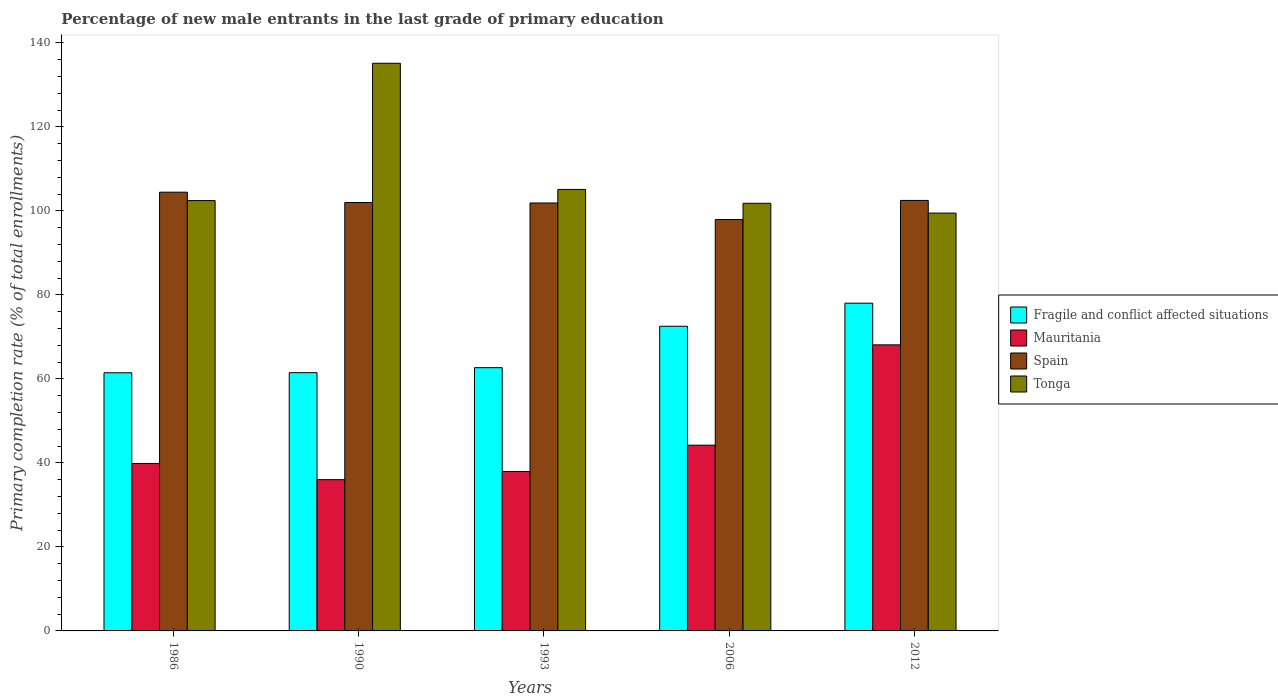How many groups of bars are there?
Offer a very short reply. 5. Are the number of bars per tick equal to the number of legend labels?
Ensure brevity in your answer.  Yes. Are the number of bars on each tick of the X-axis equal?
Provide a short and direct response. Yes. How many bars are there on the 2nd tick from the left?
Keep it short and to the point. 4. What is the percentage of new male entrants in Tonga in 2012?
Provide a succinct answer. 99.47. Across all years, what is the maximum percentage of new male entrants in Fragile and conflict affected situations?
Offer a very short reply. 78.02. Across all years, what is the minimum percentage of new male entrants in Mauritania?
Offer a terse response. 36.01. In which year was the percentage of new male entrants in Fragile and conflict affected situations minimum?
Make the answer very short. 1986. What is the total percentage of new male entrants in Mauritania in the graph?
Your answer should be very brief. 226.16. What is the difference between the percentage of new male entrants in Fragile and conflict affected situations in 1990 and that in 2006?
Offer a very short reply. -11.04. What is the difference between the percentage of new male entrants in Fragile and conflict affected situations in 1993 and the percentage of new male entrants in Spain in 1990?
Your answer should be very brief. -39.32. What is the average percentage of new male entrants in Fragile and conflict affected situations per year?
Your answer should be very brief. 67.23. In the year 1993, what is the difference between the percentage of new male entrants in Fragile and conflict affected situations and percentage of new male entrants in Mauritania?
Make the answer very short. 24.71. What is the ratio of the percentage of new male entrants in Spain in 1993 to that in 2006?
Offer a very short reply. 1.04. What is the difference between the highest and the second highest percentage of new male entrants in Spain?
Give a very brief answer. 1.96. What is the difference between the highest and the lowest percentage of new male entrants in Fragile and conflict affected situations?
Offer a very short reply. 16.56. In how many years, is the percentage of new male entrants in Spain greater than the average percentage of new male entrants in Spain taken over all years?
Keep it short and to the point. 4. Is it the case that in every year, the sum of the percentage of new male entrants in Tonga and percentage of new male entrants in Mauritania is greater than the sum of percentage of new male entrants in Fragile and conflict affected situations and percentage of new male entrants in Spain?
Keep it short and to the point. Yes. What does the 3rd bar from the left in 1990 represents?
Your answer should be very brief. Spain. What does the 1st bar from the right in 2012 represents?
Ensure brevity in your answer.  Tonga. Is it the case that in every year, the sum of the percentage of new male entrants in Tonga and percentage of new male entrants in Fragile and conflict affected situations is greater than the percentage of new male entrants in Spain?
Your answer should be very brief. Yes. Are all the bars in the graph horizontal?
Offer a terse response. No. How many years are there in the graph?
Offer a very short reply. 5. What is the difference between two consecutive major ticks on the Y-axis?
Offer a terse response. 20. Are the values on the major ticks of Y-axis written in scientific E-notation?
Provide a succinct answer. No. Does the graph contain grids?
Provide a succinct answer. No. How many legend labels are there?
Offer a terse response. 4. How are the legend labels stacked?
Your answer should be very brief. Vertical. What is the title of the graph?
Your answer should be very brief. Percentage of new male entrants in the last grade of primary education. Does "Syrian Arab Republic" appear as one of the legend labels in the graph?
Provide a succinct answer. No. What is the label or title of the X-axis?
Provide a succinct answer. Years. What is the label or title of the Y-axis?
Your response must be concise. Primary completion rate (% of total enrollments). What is the Primary completion rate (% of total enrollments) of Fragile and conflict affected situations in 1986?
Your response must be concise. 61.46. What is the Primary completion rate (% of total enrollments) in Mauritania in 1986?
Provide a short and direct response. 39.87. What is the Primary completion rate (% of total enrollments) of Spain in 1986?
Give a very brief answer. 104.44. What is the Primary completion rate (% of total enrollments) in Tonga in 1986?
Keep it short and to the point. 102.45. What is the Primary completion rate (% of total enrollments) in Fragile and conflict affected situations in 1990?
Your response must be concise. 61.48. What is the Primary completion rate (% of total enrollments) in Mauritania in 1990?
Ensure brevity in your answer.  36.01. What is the Primary completion rate (% of total enrollments) in Spain in 1990?
Ensure brevity in your answer.  101.98. What is the Primary completion rate (% of total enrollments) of Tonga in 1990?
Offer a very short reply. 135.14. What is the Primary completion rate (% of total enrollments) of Fragile and conflict affected situations in 1993?
Provide a short and direct response. 62.67. What is the Primary completion rate (% of total enrollments) of Mauritania in 1993?
Offer a terse response. 37.96. What is the Primary completion rate (% of total enrollments) in Spain in 1993?
Provide a succinct answer. 101.87. What is the Primary completion rate (% of total enrollments) of Tonga in 1993?
Provide a succinct answer. 105.1. What is the Primary completion rate (% of total enrollments) of Fragile and conflict affected situations in 2006?
Keep it short and to the point. 72.52. What is the Primary completion rate (% of total enrollments) in Mauritania in 2006?
Provide a short and direct response. 44.22. What is the Primary completion rate (% of total enrollments) in Spain in 2006?
Keep it short and to the point. 97.93. What is the Primary completion rate (% of total enrollments) in Tonga in 2006?
Your response must be concise. 101.8. What is the Primary completion rate (% of total enrollments) in Fragile and conflict affected situations in 2012?
Provide a succinct answer. 78.02. What is the Primary completion rate (% of total enrollments) in Mauritania in 2012?
Provide a short and direct response. 68.1. What is the Primary completion rate (% of total enrollments) of Spain in 2012?
Your answer should be compact. 102.48. What is the Primary completion rate (% of total enrollments) in Tonga in 2012?
Your answer should be very brief. 99.47. Across all years, what is the maximum Primary completion rate (% of total enrollments) in Fragile and conflict affected situations?
Make the answer very short. 78.02. Across all years, what is the maximum Primary completion rate (% of total enrollments) of Mauritania?
Offer a very short reply. 68.1. Across all years, what is the maximum Primary completion rate (% of total enrollments) of Spain?
Offer a terse response. 104.44. Across all years, what is the maximum Primary completion rate (% of total enrollments) of Tonga?
Keep it short and to the point. 135.14. Across all years, what is the minimum Primary completion rate (% of total enrollments) of Fragile and conflict affected situations?
Your answer should be compact. 61.46. Across all years, what is the minimum Primary completion rate (% of total enrollments) in Mauritania?
Offer a terse response. 36.01. Across all years, what is the minimum Primary completion rate (% of total enrollments) of Spain?
Offer a terse response. 97.93. Across all years, what is the minimum Primary completion rate (% of total enrollments) of Tonga?
Keep it short and to the point. 99.47. What is the total Primary completion rate (% of total enrollments) of Fragile and conflict affected situations in the graph?
Provide a short and direct response. 336.15. What is the total Primary completion rate (% of total enrollments) in Mauritania in the graph?
Your answer should be compact. 226.16. What is the total Primary completion rate (% of total enrollments) in Spain in the graph?
Your answer should be very brief. 508.71. What is the total Primary completion rate (% of total enrollments) in Tonga in the graph?
Keep it short and to the point. 543.95. What is the difference between the Primary completion rate (% of total enrollments) of Fragile and conflict affected situations in 1986 and that in 1990?
Provide a short and direct response. -0.02. What is the difference between the Primary completion rate (% of total enrollments) in Mauritania in 1986 and that in 1990?
Keep it short and to the point. 3.85. What is the difference between the Primary completion rate (% of total enrollments) of Spain in 1986 and that in 1990?
Make the answer very short. 2.46. What is the difference between the Primary completion rate (% of total enrollments) of Tonga in 1986 and that in 1990?
Provide a short and direct response. -32.69. What is the difference between the Primary completion rate (% of total enrollments) in Fragile and conflict affected situations in 1986 and that in 1993?
Offer a terse response. -1.21. What is the difference between the Primary completion rate (% of total enrollments) in Mauritania in 1986 and that in 1993?
Your answer should be very brief. 1.91. What is the difference between the Primary completion rate (% of total enrollments) of Spain in 1986 and that in 1993?
Your answer should be compact. 2.57. What is the difference between the Primary completion rate (% of total enrollments) in Tonga in 1986 and that in 1993?
Make the answer very short. -2.65. What is the difference between the Primary completion rate (% of total enrollments) in Fragile and conflict affected situations in 1986 and that in 2006?
Provide a succinct answer. -11.07. What is the difference between the Primary completion rate (% of total enrollments) of Mauritania in 1986 and that in 2006?
Your response must be concise. -4.36. What is the difference between the Primary completion rate (% of total enrollments) in Spain in 1986 and that in 2006?
Give a very brief answer. 6.51. What is the difference between the Primary completion rate (% of total enrollments) of Tonga in 1986 and that in 2006?
Your answer should be very brief. 0.65. What is the difference between the Primary completion rate (% of total enrollments) of Fragile and conflict affected situations in 1986 and that in 2012?
Your answer should be compact. -16.56. What is the difference between the Primary completion rate (% of total enrollments) of Mauritania in 1986 and that in 2012?
Your response must be concise. -28.24. What is the difference between the Primary completion rate (% of total enrollments) of Spain in 1986 and that in 2012?
Offer a terse response. 1.96. What is the difference between the Primary completion rate (% of total enrollments) in Tonga in 1986 and that in 2012?
Your answer should be very brief. 2.98. What is the difference between the Primary completion rate (% of total enrollments) in Fragile and conflict affected situations in 1990 and that in 1993?
Your response must be concise. -1.19. What is the difference between the Primary completion rate (% of total enrollments) in Mauritania in 1990 and that in 1993?
Ensure brevity in your answer.  -1.94. What is the difference between the Primary completion rate (% of total enrollments) in Spain in 1990 and that in 1993?
Your answer should be compact. 0.11. What is the difference between the Primary completion rate (% of total enrollments) of Tonga in 1990 and that in 1993?
Your answer should be compact. 30.04. What is the difference between the Primary completion rate (% of total enrollments) in Fragile and conflict affected situations in 1990 and that in 2006?
Provide a succinct answer. -11.04. What is the difference between the Primary completion rate (% of total enrollments) in Mauritania in 1990 and that in 2006?
Your answer should be very brief. -8.21. What is the difference between the Primary completion rate (% of total enrollments) in Spain in 1990 and that in 2006?
Your answer should be compact. 4.05. What is the difference between the Primary completion rate (% of total enrollments) in Tonga in 1990 and that in 2006?
Keep it short and to the point. 33.34. What is the difference between the Primary completion rate (% of total enrollments) in Fragile and conflict affected situations in 1990 and that in 2012?
Provide a succinct answer. -16.54. What is the difference between the Primary completion rate (% of total enrollments) in Mauritania in 1990 and that in 2012?
Make the answer very short. -32.09. What is the difference between the Primary completion rate (% of total enrollments) of Spain in 1990 and that in 2012?
Offer a terse response. -0.5. What is the difference between the Primary completion rate (% of total enrollments) in Tonga in 1990 and that in 2012?
Provide a short and direct response. 35.67. What is the difference between the Primary completion rate (% of total enrollments) of Fragile and conflict affected situations in 1993 and that in 2006?
Ensure brevity in your answer.  -9.86. What is the difference between the Primary completion rate (% of total enrollments) in Mauritania in 1993 and that in 2006?
Offer a terse response. -6.27. What is the difference between the Primary completion rate (% of total enrollments) of Spain in 1993 and that in 2006?
Make the answer very short. 3.94. What is the difference between the Primary completion rate (% of total enrollments) in Tonga in 1993 and that in 2006?
Offer a very short reply. 3.3. What is the difference between the Primary completion rate (% of total enrollments) of Fragile and conflict affected situations in 1993 and that in 2012?
Your answer should be very brief. -15.35. What is the difference between the Primary completion rate (% of total enrollments) in Mauritania in 1993 and that in 2012?
Offer a terse response. -30.15. What is the difference between the Primary completion rate (% of total enrollments) of Spain in 1993 and that in 2012?
Keep it short and to the point. -0.61. What is the difference between the Primary completion rate (% of total enrollments) in Tonga in 1993 and that in 2012?
Your response must be concise. 5.63. What is the difference between the Primary completion rate (% of total enrollments) of Fragile and conflict affected situations in 2006 and that in 2012?
Provide a short and direct response. -5.49. What is the difference between the Primary completion rate (% of total enrollments) in Mauritania in 2006 and that in 2012?
Your answer should be very brief. -23.88. What is the difference between the Primary completion rate (% of total enrollments) of Spain in 2006 and that in 2012?
Give a very brief answer. -4.55. What is the difference between the Primary completion rate (% of total enrollments) in Tonga in 2006 and that in 2012?
Your response must be concise. 2.33. What is the difference between the Primary completion rate (% of total enrollments) of Fragile and conflict affected situations in 1986 and the Primary completion rate (% of total enrollments) of Mauritania in 1990?
Ensure brevity in your answer.  25.44. What is the difference between the Primary completion rate (% of total enrollments) in Fragile and conflict affected situations in 1986 and the Primary completion rate (% of total enrollments) in Spain in 1990?
Your answer should be very brief. -40.53. What is the difference between the Primary completion rate (% of total enrollments) of Fragile and conflict affected situations in 1986 and the Primary completion rate (% of total enrollments) of Tonga in 1990?
Your response must be concise. -73.68. What is the difference between the Primary completion rate (% of total enrollments) of Mauritania in 1986 and the Primary completion rate (% of total enrollments) of Spain in 1990?
Your answer should be very brief. -62.12. What is the difference between the Primary completion rate (% of total enrollments) of Mauritania in 1986 and the Primary completion rate (% of total enrollments) of Tonga in 1990?
Your answer should be very brief. -95.27. What is the difference between the Primary completion rate (% of total enrollments) of Spain in 1986 and the Primary completion rate (% of total enrollments) of Tonga in 1990?
Your answer should be very brief. -30.69. What is the difference between the Primary completion rate (% of total enrollments) of Fragile and conflict affected situations in 1986 and the Primary completion rate (% of total enrollments) of Mauritania in 1993?
Provide a short and direct response. 23.5. What is the difference between the Primary completion rate (% of total enrollments) in Fragile and conflict affected situations in 1986 and the Primary completion rate (% of total enrollments) in Spain in 1993?
Your answer should be very brief. -40.41. What is the difference between the Primary completion rate (% of total enrollments) in Fragile and conflict affected situations in 1986 and the Primary completion rate (% of total enrollments) in Tonga in 1993?
Offer a very short reply. -43.64. What is the difference between the Primary completion rate (% of total enrollments) in Mauritania in 1986 and the Primary completion rate (% of total enrollments) in Spain in 1993?
Offer a terse response. -62. What is the difference between the Primary completion rate (% of total enrollments) in Mauritania in 1986 and the Primary completion rate (% of total enrollments) in Tonga in 1993?
Make the answer very short. -65.23. What is the difference between the Primary completion rate (% of total enrollments) of Spain in 1986 and the Primary completion rate (% of total enrollments) of Tonga in 1993?
Your response must be concise. -0.65. What is the difference between the Primary completion rate (% of total enrollments) of Fragile and conflict affected situations in 1986 and the Primary completion rate (% of total enrollments) of Mauritania in 2006?
Provide a succinct answer. 17.23. What is the difference between the Primary completion rate (% of total enrollments) in Fragile and conflict affected situations in 1986 and the Primary completion rate (% of total enrollments) in Spain in 2006?
Your response must be concise. -36.48. What is the difference between the Primary completion rate (% of total enrollments) of Fragile and conflict affected situations in 1986 and the Primary completion rate (% of total enrollments) of Tonga in 2006?
Your response must be concise. -40.34. What is the difference between the Primary completion rate (% of total enrollments) in Mauritania in 1986 and the Primary completion rate (% of total enrollments) in Spain in 2006?
Your answer should be compact. -58.07. What is the difference between the Primary completion rate (% of total enrollments) in Mauritania in 1986 and the Primary completion rate (% of total enrollments) in Tonga in 2006?
Your response must be concise. -61.93. What is the difference between the Primary completion rate (% of total enrollments) in Spain in 1986 and the Primary completion rate (% of total enrollments) in Tonga in 2006?
Ensure brevity in your answer.  2.65. What is the difference between the Primary completion rate (% of total enrollments) of Fragile and conflict affected situations in 1986 and the Primary completion rate (% of total enrollments) of Mauritania in 2012?
Your response must be concise. -6.65. What is the difference between the Primary completion rate (% of total enrollments) in Fragile and conflict affected situations in 1986 and the Primary completion rate (% of total enrollments) in Spain in 2012?
Keep it short and to the point. -41.02. What is the difference between the Primary completion rate (% of total enrollments) in Fragile and conflict affected situations in 1986 and the Primary completion rate (% of total enrollments) in Tonga in 2012?
Your answer should be compact. -38.01. What is the difference between the Primary completion rate (% of total enrollments) in Mauritania in 1986 and the Primary completion rate (% of total enrollments) in Spain in 2012?
Ensure brevity in your answer.  -62.62. What is the difference between the Primary completion rate (% of total enrollments) in Mauritania in 1986 and the Primary completion rate (% of total enrollments) in Tonga in 2012?
Make the answer very short. -59.6. What is the difference between the Primary completion rate (% of total enrollments) in Spain in 1986 and the Primary completion rate (% of total enrollments) in Tonga in 2012?
Make the answer very short. 4.98. What is the difference between the Primary completion rate (% of total enrollments) of Fragile and conflict affected situations in 1990 and the Primary completion rate (% of total enrollments) of Mauritania in 1993?
Provide a short and direct response. 23.52. What is the difference between the Primary completion rate (% of total enrollments) in Fragile and conflict affected situations in 1990 and the Primary completion rate (% of total enrollments) in Spain in 1993?
Keep it short and to the point. -40.39. What is the difference between the Primary completion rate (% of total enrollments) in Fragile and conflict affected situations in 1990 and the Primary completion rate (% of total enrollments) in Tonga in 1993?
Give a very brief answer. -43.62. What is the difference between the Primary completion rate (% of total enrollments) in Mauritania in 1990 and the Primary completion rate (% of total enrollments) in Spain in 1993?
Your answer should be compact. -65.86. What is the difference between the Primary completion rate (% of total enrollments) in Mauritania in 1990 and the Primary completion rate (% of total enrollments) in Tonga in 1993?
Provide a short and direct response. -69.09. What is the difference between the Primary completion rate (% of total enrollments) of Spain in 1990 and the Primary completion rate (% of total enrollments) of Tonga in 1993?
Offer a very short reply. -3.11. What is the difference between the Primary completion rate (% of total enrollments) in Fragile and conflict affected situations in 1990 and the Primary completion rate (% of total enrollments) in Mauritania in 2006?
Provide a succinct answer. 17.26. What is the difference between the Primary completion rate (% of total enrollments) in Fragile and conflict affected situations in 1990 and the Primary completion rate (% of total enrollments) in Spain in 2006?
Your answer should be compact. -36.45. What is the difference between the Primary completion rate (% of total enrollments) of Fragile and conflict affected situations in 1990 and the Primary completion rate (% of total enrollments) of Tonga in 2006?
Offer a very short reply. -40.32. What is the difference between the Primary completion rate (% of total enrollments) in Mauritania in 1990 and the Primary completion rate (% of total enrollments) in Spain in 2006?
Provide a succinct answer. -61.92. What is the difference between the Primary completion rate (% of total enrollments) in Mauritania in 1990 and the Primary completion rate (% of total enrollments) in Tonga in 2006?
Your response must be concise. -65.79. What is the difference between the Primary completion rate (% of total enrollments) in Spain in 1990 and the Primary completion rate (% of total enrollments) in Tonga in 2006?
Your answer should be very brief. 0.19. What is the difference between the Primary completion rate (% of total enrollments) of Fragile and conflict affected situations in 1990 and the Primary completion rate (% of total enrollments) of Mauritania in 2012?
Provide a short and direct response. -6.62. What is the difference between the Primary completion rate (% of total enrollments) of Fragile and conflict affected situations in 1990 and the Primary completion rate (% of total enrollments) of Spain in 2012?
Your answer should be very brief. -41. What is the difference between the Primary completion rate (% of total enrollments) of Fragile and conflict affected situations in 1990 and the Primary completion rate (% of total enrollments) of Tonga in 2012?
Provide a succinct answer. -37.99. What is the difference between the Primary completion rate (% of total enrollments) in Mauritania in 1990 and the Primary completion rate (% of total enrollments) in Spain in 2012?
Keep it short and to the point. -66.47. What is the difference between the Primary completion rate (% of total enrollments) of Mauritania in 1990 and the Primary completion rate (% of total enrollments) of Tonga in 2012?
Make the answer very short. -63.46. What is the difference between the Primary completion rate (% of total enrollments) of Spain in 1990 and the Primary completion rate (% of total enrollments) of Tonga in 2012?
Keep it short and to the point. 2.52. What is the difference between the Primary completion rate (% of total enrollments) in Fragile and conflict affected situations in 1993 and the Primary completion rate (% of total enrollments) in Mauritania in 2006?
Give a very brief answer. 18.45. What is the difference between the Primary completion rate (% of total enrollments) of Fragile and conflict affected situations in 1993 and the Primary completion rate (% of total enrollments) of Spain in 2006?
Ensure brevity in your answer.  -35.26. What is the difference between the Primary completion rate (% of total enrollments) in Fragile and conflict affected situations in 1993 and the Primary completion rate (% of total enrollments) in Tonga in 2006?
Make the answer very short. -39.13. What is the difference between the Primary completion rate (% of total enrollments) in Mauritania in 1993 and the Primary completion rate (% of total enrollments) in Spain in 2006?
Ensure brevity in your answer.  -59.98. What is the difference between the Primary completion rate (% of total enrollments) of Mauritania in 1993 and the Primary completion rate (% of total enrollments) of Tonga in 2006?
Give a very brief answer. -63.84. What is the difference between the Primary completion rate (% of total enrollments) of Spain in 1993 and the Primary completion rate (% of total enrollments) of Tonga in 2006?
Your response must be concise. 0.07. What is the difference between the Primary completion rate (% of total enrollments) in Fragile and conflict affected situations in 1993 and the Primary completion rate (% of total enrollments) in Mauritania in 2012?
Offer a very short reply. -5.43. What is the difference between the Primary completion rate (% of total enrollments) in Fragile and conflict affected situations in 1993 and the Primary completion rate (% of total enrollments) in Spain in 2012?
Your answer should be very brief. -39.81. What is the difference between the Primary completion rate (% of total enrollments) in Fragile and conflict affected situations in 1993 and the Primary completion rate (% of total enrollments) in Tonga in 2012?
Your answer should be very brief. -36.8. What is the difference between the Primary completion rate (% of total enrollments) in Mauritania in 1993 and the Primary completion rate (% of total enrollments) in Spain in 2012?
Your answer should be very brief. -64.52. What is the difference between the Primary completion rate (% of total enrollments) in Mauritania in 1993 and the Primary completion rate (% of total enrollments) in Tonga in 2012?
Ensure brevity in your answer.  -61.51. What is the difference between the Primary completion rate (% of total enrollments) of Spain in 1993 and the Primary completion rate (% of total enrollments) of Tonga in 2012?
Keep it short and to the point. 2.4. What is the difference between the Primary completion rate (% of total enrollments) of Fragile and conflict affected situations in 2006 and the Primary completion rate (% of total enrollments) of Mauritania in 2012?
Offer a terse response. 4.42. What is the difference between the Primary completion rate (% of total enrollments) in Fragile and conflict affected situations in 2006 and the Primary completion rate (% of total enrollments) in Spain in 2012?
Offer a very short reply. -29.96. What is the difference between the Primary completion rate (% of total enrollments) in Fragile and conflict affected situations in 2006 and the Primary completion rate (% of total enrollments) in Tonga in 2012?
Keep it short and to the point. -26.94. What is the difference between the Primary completion rate (% of total enrollments) in Mauritania in 2006 and the Primary completion rate (% of total enrollments) in Spain in 2012?
Make the answer very short. -58.26. What is the difference between the Primary completion rate (% of total enrollments) in Mauritania in 2006 and the Primary completion rate (% of total enrollments) in Tonga in 2012?
Offer a very short reply. -55.25. What is the difference between the Primary completion rate (% of total enrollments) of Spain in 2006 and the Primary completion rate (% of total enrollments) of Tonga in 2012?
Your answer should be compact. -1.54. What is the average Primary completion rate (% of total enrollments) of Fragile and conflict affected situations per year?
Your response must be concise. 67.23. What is the average Primary completion rate (% of total enrollments) of Mauritania per year?
Keep it short and to the point. 45.23. What is the average Primary completion rate (% of total enrollments) of Spain per year?
Provide a succinct answer. 101.74. What is the average Primary completion rate (% of total enrollments) in Tonga per year?
Your answer should be very brief. 108.79. In the year 1986, what is the difference between the Primary completion rate (% of total enrollments) in Fragile and conflict affected situations and Primary completion rate (% of total enrollments) in Mauritania?
Make the answer very short. 21.59. In the year 1986, what is the difference between the Primary completion rate (% of total enrollments) of Fragile and conflict affected situations and Primary completion rate (% of total enrollments) of Spain?
Give a very brief answer. -42.99. In the year 1986, what is the difference between the Primary completion rate (% of total enrollments) in Fragile and conflict affected situations and Primary completion rate (% of total enrollments) in Tonga?
Offer a terse response. -40.99. In the year 1986, what is the difference between the Primary completion rate (% of total enrollments) of Mauritania and Primary completion rate (% of total enrollments) of Spain?
Offer a very short reply. -64.58. In the year 1986, what is the difference between the Primary completion rate (% of total enrollments) in Mauritania and Primary completion rate (% of total enrollments) in Tonga?
Your response must be concise. -62.58. In the year 1986, what is the difference between the Primary completion rate (% of total enrollments) in Spain and Primary completion rate (% of total enrollments) in Tonga?
Your response must be concise. 2. In the year 1990, what is the difference between the Primary completion rate (% of total enrollments) in Fragile and conflict affected situations and Primary completion rate (% of total enrollments) in Mauritania?
Your answer should be compact. 25.47. In the year 1990, what is the difference between the Primary completion rate (% of total enrollments) in Fragile and conflict affected situations and Primary completion rate (% of total enrollments) in Spain?
Offer a terse response. -40.5. In the year 1990, what is the difference between the Primary completion rate (% of total enrollments) in Fragile and conflict affected situations and Primary completion rate (% of total enrollments) in Tonga?
Ensure brevity in your answer.  -73.65. In the year 1990, what is the difference between the Primary completion rate (% of total enrollments) in Mauritania and Primary completion rate (% of total enrollments) in Spain?
Your answer should be compact. -65.97. In the year 1990, what is the difference between the Primary completion rate (% of total enrollments) in Mauritania and Primary completion rate (% of total enrollments) in Tonga?
Offer a terse response. -99.12. In the year 1990, what is the difference between the Primary completion rate (% of total enrollments) in Spain and Primary completion rate (% of total enrollments) in Tonga?
Provide a succinct answer. -33.15. In the year 1993, what is the difference between the Primary completion rate (% of total enrollments) of Fragile and conflict affected situations and Primary completion rate (% of total enrollments) of Mauritania?
Provide a succinct answer. 24.71. In the year 1993, what is the difference between the Primary completion rate (% of total enrollments) in Fragile and conflict affected situations and Primary completion rate (% of total enrollments) in Spain?
Ensure brevity in your answer.  -39.2. In the year 1993, what is the difference between the Primary completion rate (% of total enrollments) in Fragile and conflict affected situations and Primary completion rate (% of total enrollments) in Tonga?
Keep it short and to the point. -42.43. In the year 1993, what is the difference between the Primary completion rate (% of total enrollments) of Mauritania and Primary completion rate (% of total enrollments) of Spain?
Your response must be concise. -63.91. In the year 1993, what is the difference between the Primary completion rate (% of total enrollments) of Mauritania and Primary completion rate (% of total enrollments) of Tonga?
Your response must be concise. -67.14. In the year 1993, what is the difference between the Primary completion rate (% of total enrollments) in Spain and Primary completion rate (% of total enrollments) in Tonga?
Provide a succinct answer. -3.23. In the year 2006, what is the difference between the Primary completion rate (% of total enrollments) in Fragile and conflict affected situations and Primary completion rate (% of total enrollments) in Mauritania?
Make the answer very short. 28.3. In the year 2006, what is the difference between the Primary completion rate (% of total enrollments) in Fragile and conflict affected situations and Primary completion rate (% of total enrollments) in Spain?
Give a very brief answer. -25.41. In the year 2006, what is the difference between the Primary completion rate (% of total enrollments) of Fragile and conflict affected situations and Primary completion rate (% of total enrollments) of Tonga?
Your answer should be compact. -29.27. In the year 2006, what is the difference between the Primary completion rate (% of total enrollments) of Mauritania and Primary completion rate (% of total enrollments) of Spain?
Your response must be concise. -53.71. In the year 2006, what is the difference between the Primary completion rate (% of total enrollments) in Mauritania and Primary completion rate (% of total enrollments) in Tonga?
Make the answer very short. -57.58. In the year 2006, what is the difference between the Primary completion rate (% of total enrollments) in Spain and Primary completion rate (% of total enrollments) in Tonga?
Offer a terse response. -3.87. In the year 2012, what is the difference between the Primary completion rate (% of total enrollments) in Fragile and conflict affected situations and Primary completion rate (% of total enrollments) in Mauritania?
Offer a terse response. 9.92. In the year 2012, what is the difference between the Primary completion rate (% of total enrollments) of Fragile and conflict affected situations and Primary completion rate (% of total enrollments) of Spain?
Offer a very short reply. -24.46. In the year 2012, what is the difference between the Primary completion rate (% of total enrollments) in Fragile and conflict affected situations and Primary completion rate (% of total enrollments) in Tonga?
Your answer should be very brief. -21.45. In the year 2012, what is the difference between the Primary completion rate (% of total enrollments) of Mauritania and Primary completion rate (% of total enrollments) of Spain?
Your answer should be very brief. -34.38. In the year 2012, what is the difference between the Primary completion rate (% of total enrollments) of Mauritania and Primary completion rate (% of total enrollments) of Tonga?
Give a very brief answer. -31.37. In the year 2012, what is the difference between the Primary completion rate (% of total enrollments) in Spain and Primary completion rate (% of total enrollments) in Tonga?
Make the answer very short. 3.01. What is the ratio of the Primary completion rate (% of total enrollments) in Fragile and conflict affected situations in 1986 to that in 1990?
Provide a succinct answer. 1. What is the ratio of the Primary completion rate (% of total enrollments) in Mauritania in 1986 to that in 1990?
Your response must be concise. 1.11. What is the ratio of the Primary completion rate (% of total enrollments) of Spain in 1986 to that in 1990?
Keep it short and to the point. 1.02. What is the ratio of the Primary completion rate (% of total enrollments) in Tonga in 1986 to that in 1990?
Keep it short and to the point. 0.76. What is the ratio of the Primary completion rate (% of total enrollments) in Fragile and conflict affected situations in 1986 to that in 1993?
Keep it short and to the point. 0.98. What is the ratio of the Primary completion rate (% of total enrollments) in Mauritania in 1986 to that in 1993?
Provide a short and direct response. 1.05. What is the ratio of the Primary completion rate (% of total enrollments) in Spain in 1986 to that in 1993?
Your response must be concise. 1.03. What is the ratio of the Primary completion rate (% of total enrollments) of Tonga in 1986 to that in 1993?
Your response must be concise. 0.97. What is the ratio of the Primary completion rate (% of total enrollments) in Fragile and conflict affected situations in 1986 to that in 2006?
Keep it short and to the point. 0.85. What is the ratio of the Primary completion rate (% of total enrollments) in Mauritania in 1986 to that in 2006?
Give a very brief answer. 0.9. What is the ratio of the Primary completion rate (% of total enrollments) in Spain in 1986 to that in 2006?
Offer a terse response. 1.07. What is the ratio of the Primary completion rate (% of total enrollments) in Fragile and conflict affected situations in 1986 to that in 2012?
Provide a short and direct response. 0.79. What is the ratio of the Primary completion rate (% of total enrollments) of Mauritania in 1986 to that in 2012?
Provide a succinct answer. 0.59. What is the ratio of the Primary completion rate (% of total enrollments) of Spain in 1986 to that in 2012?
Provide a short and direct response. 1.02. What is the ratio of the Primary completion rate (% of total enrollments) in Tonga in 1986 to that in 2012?
Give a very brief answer. 1.03. What is the ratio of the Primary completion rate (% of total enrollments) of Mauritania in 1990 to that in 1993?
Your answer should be very brief. 0.95. What is the ratio of the Primary completion rate (% of total enrollments) of Tonga in 1990 to that in 1993?
Keep it short and to the point. 1.29. What is the ratio of the Primary completion rate (% of total enrollments) of Fragile and conflict affected situations in 1990 to that in 2006?
Your answer should be compact. 0.85. What is the ratio of the Primary completion rate (% of total enrollments) in Mauritania in 1990 to that in 2006?
Your response must be concise. 0.81. What is the ratio of the Primary completion rate (% of total enrollments) in Spain in 1990 to that in 2006?
Make the answer very short. 1.04. What is the ratio of the Primary completion rate (% of total enrollments) in Tonga in 1990 to that in 2006?
Keep it short and to the point. 1.33. What is the ratio of the Primary completion rate (% of total enrollments) of Fragile and conflict affected situations in 1990 to that in 2012?
Keep it short and to the point. 0.79. What is the ratio of the Primary completion rate (% of total enrollments) of Mauritania in 1990 to that in 2012?
Ensure brevity in your answer.  0.53. What is the ratio of the Primary completion rate (% of total enrollments) in Tonga in 1990 to that in 2012?
Provide a short and direct response. 1.36. What is the ratio of the Primary completion rate (% of total enrollments) in Fragile and conflict affected situations in 1993 to that in 2006?
Your response must be concise. 0.86. What is the ratio of the Primary completion rate (% of total enrollments) in Mauritania in 1993 to that in 2006?
Your answer should be compact. 0.86. What is the ratio of the Primary completion rate (% of total enrollments) in Spain in 1993 to that in 2006?
Offer a very short reply. 1.04. What is the ratio of the Primary completion rate (% of total enrollments) in Tonga in 1993 to that in 2006?
Offer a terse response. 1.03. What is the ratio of the Primary completion rate (% of total enrollments) of Fragile and conflict affected situations in 1993 to that in 2012?
Keep it short and to the point. 0.8. What is the ratio of the Primary completion rate (% of total enrollments) of Mauritania in 1993 to that in 2012?
Your response must be concise. 0.56. What is the ratio of the Primary completion rate (% of total enrollments) in Tonga in 1993 to that in 2012?
Provide a succinct answer. 1.06. What is the ratio of the Primary completion rate (% of total enrollments) in Fragile and conflict affected situations in 2006 to that in 2012?
Your answer should be very brief. 0.93. What is the ratio of the Primary completion rate (% of total enrollments) of Mauritania in 2006 to that in 2012?
Keep it short and to the point. 0.65. What is the ratio of the Primary completion rate (% of total enrollments) in Spain in 2006 to that in 2012?
Your response must be concise. 0.96. What is the ratio of the Primary completion rate (% of total enrollments) in Tonga in 2006 to that in 2012?
Ensure brevity in your answer.  1.02. What is the difference between the highest and the second highest Primary completion rate (% of total enrollments) in Fragile and conflict affected situations?
Your answer should be compact. 5.49. What is the difference between the highest and the second highest Primary completion rate (% of total enrollments) in Mauritania?
Keep it short and to the point. 23.88. What is the difference between the highest and the second highest Primary completion rate (% of total enrollments) in Spain?
Your answer should be very brief. 1.96. What is the difference between the highest and the second highest Primary completion rate (% of total enrollments) of Tonga?
Offer a very short reply. 30.04. What is the difference between the highest and the lowest Primary completion rate (% of total enrollments) in Fragile and conflict affected situations?
Your response must be concise. 16.56. What is the difference between the highest and the lowest Primary completion rate (% of total enrollments) in Mauritania?
Keep it short and to the point. 32.09. What is the difference between the highest and the lowest Primary completion rate (% of total enrollments) of Spain?
Offer a terse response. 6.51. What is the difference between the highest and the lowest Primary completion rate (% of total enrollments) in Tonga?
Your answer should be compact. 35.67. 